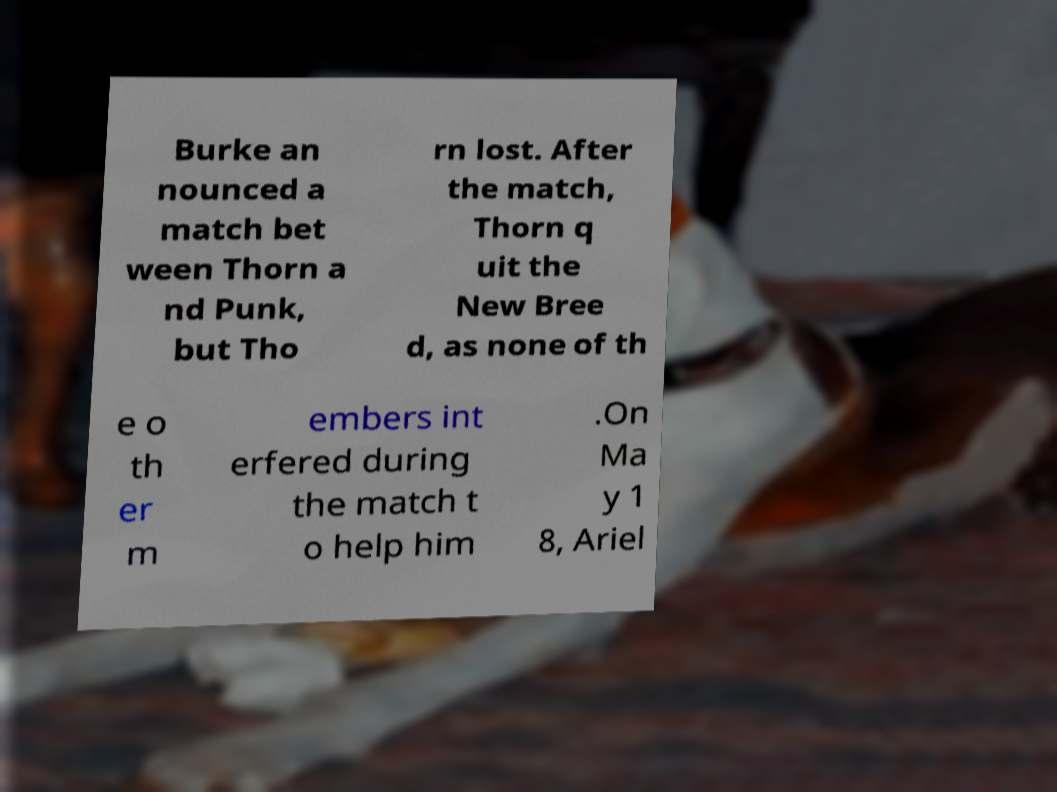Please read and relay the text visible in this image. What does it say? Burke an nounced a match bet ween Thorn a nd Punk, but Tho rn lost. After the match, Thorn q uit the New Bree d, as none of th e o th er m embers int erfered during the match t o help him .On Ma y 1 8, Ariel 